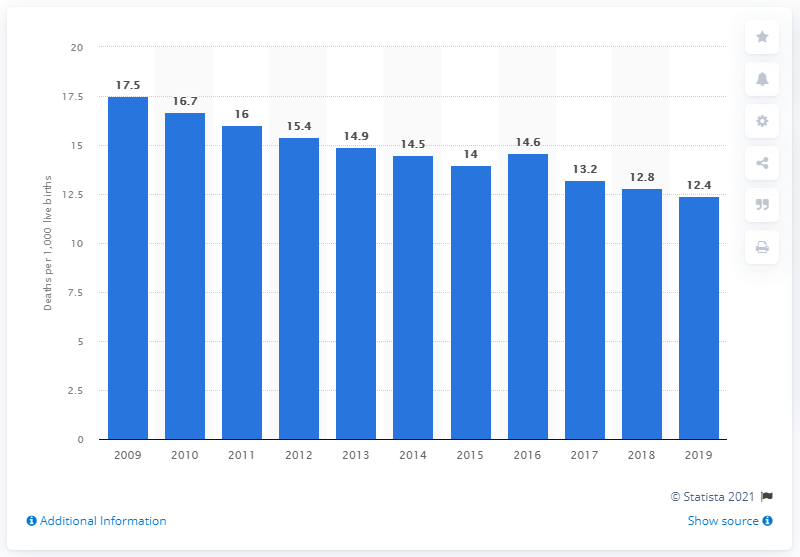Give some essential details in this illustration. In 2019, the infant mortality rate in Brazil was 12.4. 